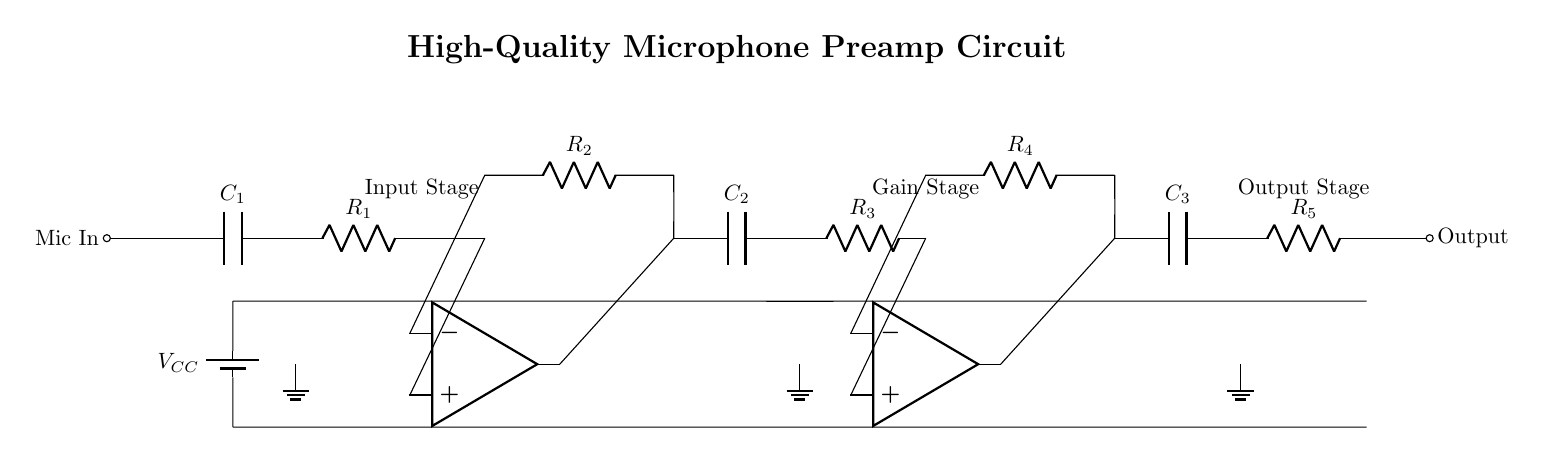What type of circuit is this? This circuit is a microphone preamp, specifically designed to amplify weak audio signals from microphones. It enhances the quality of audio recording by boosting the microphone's output.
Answer: microphone preamp What is the value of the capacitor in the input stage? In the circuit diagram, the input stage capacitor is labeled as C1, but the value is not specified in the diagram. Typically, it is in the range of microfarads for audio applications.
Answer: not specified How many operational amplifiers are in this circuit? The circuit shows two operational amplifiers, one in the input stage and another in the gain stage. They are essential for signal amplification.
Answer: two What is the function of the resistor R3? Resistor R3 is part of the gain stage, which sets the gain of the operational amplifier, affecting the overall amplification of the microphone signal.
Answer: gain control What is the purpose of capacitor C3? Capacitor C3 in the output stage typically serves for DC blocking, allowing AC signals to pass while preventing DC voltage from reaching the output, ensuring a cleaner output signal.
Answer: DC blocking What are the ground connections used for? The ground connections in the circuit provide a common reference point for all signals and power supplies, establishing a stable circuit operation and reducing noise.
Answer: common reference What is the power supply voltage labeled in the circuit? The power supply voltage is labeled as VCC in the diagram, which is commonly used to indicate the supply voltage for the operational amplifiers and other components in the circuit.
Answer: VCC 